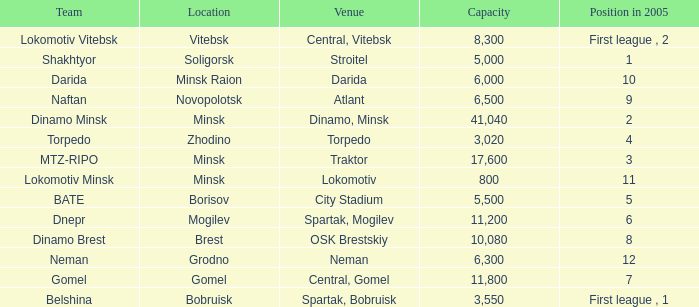Would you mind parsing the complete table? {'header': ['Team', 'Location', 'Venue', 'Capacity', 'Position in 2005'], 'rows': [['Lokomotiv Vitebsk', 'Vitebsk', 'Central, Vitebsk', '8,300', 'First league , 2'], ['Shakhtyor', 'Soligorsk', 'Stroitel', '5,000', '1'], ['Darida', 'Minsk Raion', 'Darida', '6,000', '10'], ['Naftan', 'Novopolotsk', 'Atlant', '6,500', '9'], ['Dinamo Minsk', 'Minsk', 'Dinamo, Minsk', '41,040', '2'], ['Torpedo', 'Zhodino', 'Torpedo', '3,020', '4'], ['MTZ-RIPO', 'Minsk', 'Traktor', '17,600', '3'], ['Lokomotiv Minsk', 'Minsk', 'Lokomotiv', '800', '11'], ['BATE', 'Borisov', 'City Stadium', '5,500', '5'], ['Dnepr', 'Mogilev', 'Spartak, Mogilev', '11,200', '6'], ['Dinamo Brest', 'Brest', 'OSK Brestskiy', '10,080', '8'], ['Neman', 'Grodno', 'Neman', '6,300', '12'], ['Gomel', 'Gomel', 'Central, Gomel', '11,800', '7'], ['Belshina', 'Bobruisk', 'Spartak, Bobruisk', '3,550', 'First league , 1']]} Can you tell me the highest Capacity that has the Team of torpedo? 3020.0. 